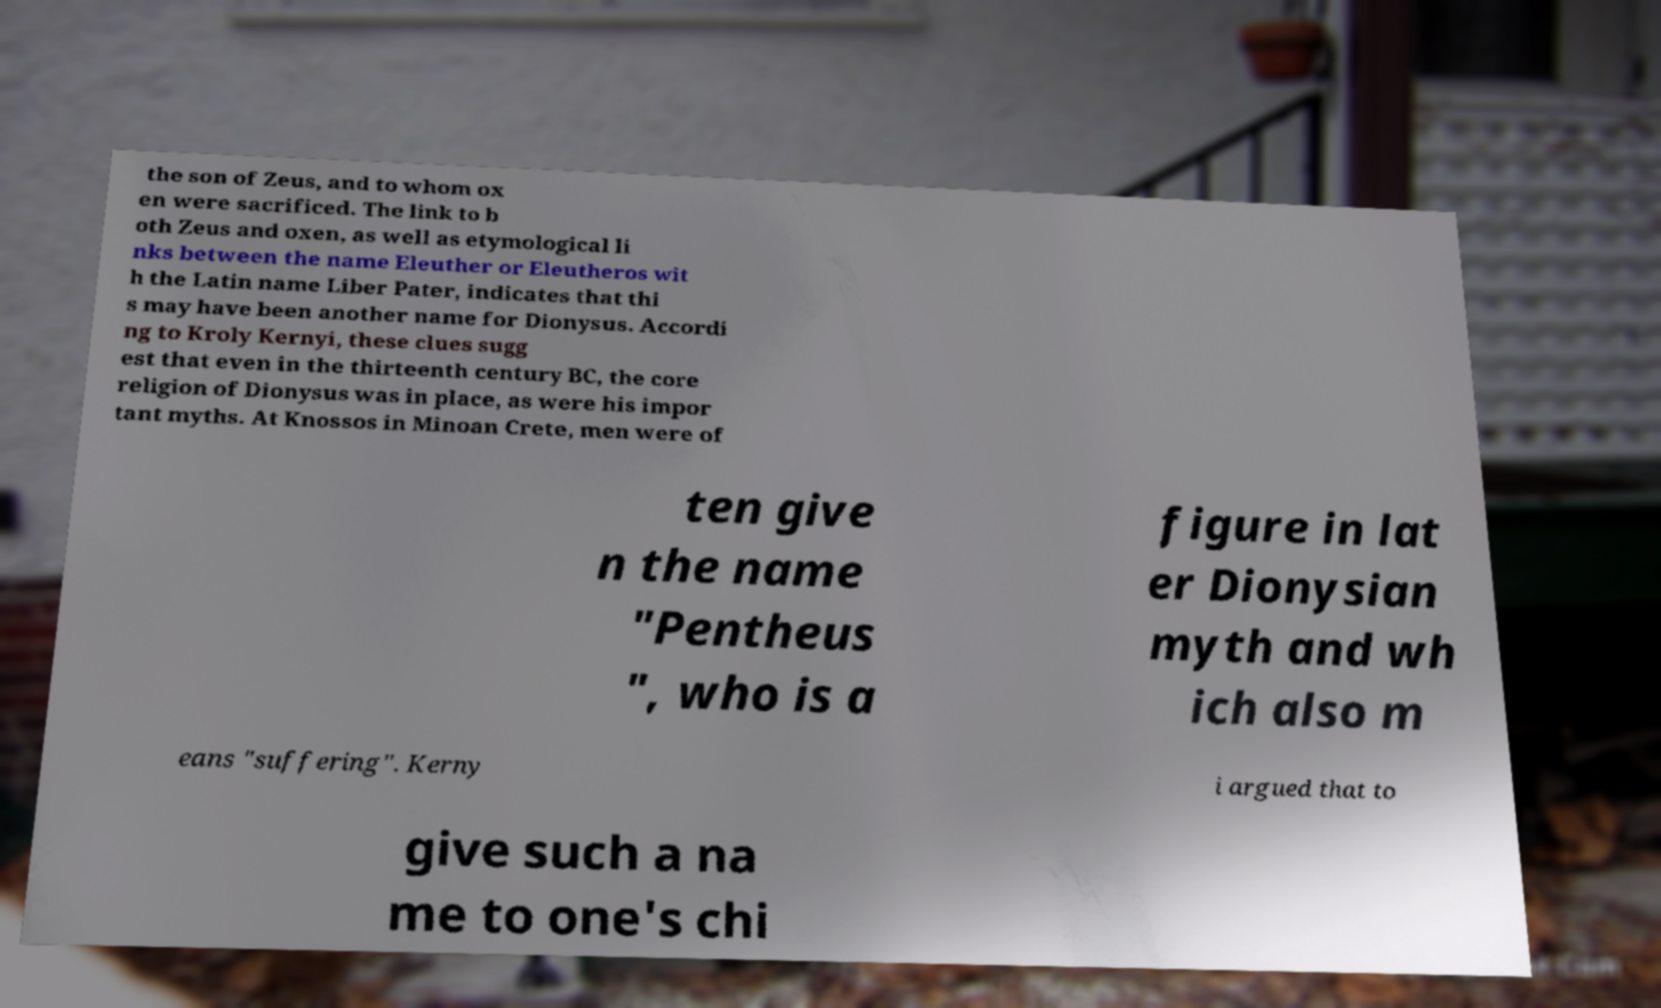What messages or text are displayed in this image? I need them in a readable, typed format. the son of Zeus, and to whom ox en were sacrificed. The link to b oth Zeus and oxen, as well as etymological li nks between the name Eleuther or Eleutheros wit h the Latin name Liber Pater, indicates that thi s may have been another name for Dionysus. Accordi ng to Kroly Kernyi, these clues sugg est that even in the thirteenth century BC, the core religion of Dionysus was in place, as were his impor tant myths. At Knossos in Minoan Crete, men were of ten give n the name "Pentheus ", who is a figure in lat er Dionysian myth and wh ich also m eans "suffering". Kerny i argued that to give such a na me to one's chi 